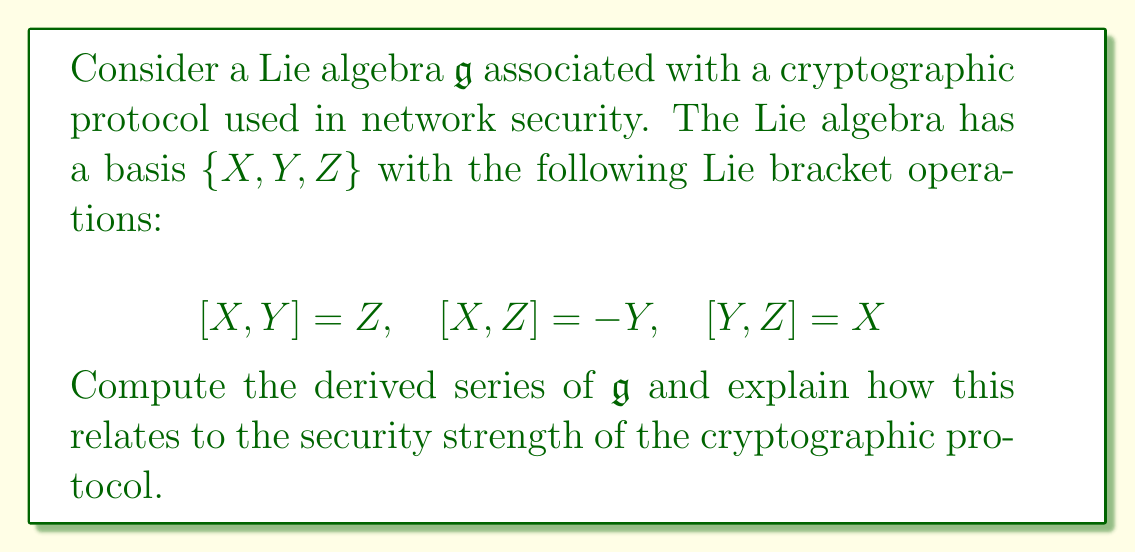Solve this math problem. To compute the derived series of the Lie algebra $\mathfrak{g}$, we need to iteratively calculate the derived subalgebras. Let's proceed step by step:

1) First, recall that the derived series is defined as:
   $\mathfrak{g}^{(0)} = \mathfrak{g}$, $\mathfrak{g}^{(1)} = [\mathfrak{g},\mathfrak{g}]$, $\mathfrak{g}^{(2)} = [\mathfrak{g}^{(1)},\mathfrak{g}^{(1)}]$, and so on.

2) We start with $\mathfrak{g}^{(0)} = \mathfrak{g} = \text{span}\{X,Y,Z\}$.

3) To find $\mathfrak{g}^{(1)}$, we compute $[\mathfrak{g},\mathfrak{g}]$:
   $[X,Y] = Z$, $[X,Z] = -Y$, $[Y,Z] = X$
   This shows that $\mathfrak{g}^{(1)} = \text{span}\{X,Y,Z\} = \mathfrak{g}$.

4) Since $\mathfrak{g}^{(1)} = \mathfrak{g}$, we have $\mathfrak{g}^{(2)} = [\mathfrak{g}^{(1)},\mathfrak{g}^{(1)}] = [\mathfrak{g},\mathfrak{g}] = \mathfrak{g}^{(1)} = \mathfrak{g}$.

5) This pattern continues indefinitely, so the derived series is:
   $\mathfrak{g} = \mathfrak{g}^{(0)} = \mathfrak{g}^{(1)} = \mathfrak{g}^{(2)} = \cdots$

Relating this to cryptographic protocols and network security:

1) The derived series not terminating at 0 indicates that the Lie algebra is not solvable. In cryptographic terms, this suggests that the protocol based on this algebra might be more resistant to certain algebraic attacks.

2) The fact that $\mathfrak{g}^{(1)} = \mathfrak{g}$ means the Lie algebra is perfect. Perfect Lie algebras are often associated with more complex algebraic structures, which can translate to stronger cryptographic protocols.

3) In network security, protocols based on such algebraic structures may offer better resistance against structural attacks and maintain their security properties even after multiple iterations or rounds of the protocol.

4) However, the simplicity of the derived series (all terms being equal to $\mathfrak{g}$) might also indicate a potential weakness if an attacker can exploit this regularity in the algebraic structure.
Answer: The derived series of $\mathfrak{g}$ is $\mathfrak{g} = \mathfrak{g}^{(0)} = \mathfrak{g}^{(1)} = \mathfrak{g}^{(2)} = \cdots$. This indicates that $\mathfrak{g}$ is a perfect Lie algebra, which can potentially provide strong security properties for the associated cryptographic protocol, but the regularity in the series should be carefully analyzed for potential vulnerabilities. 